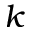Convert formula to latex. <formula><loc_0><loc_0><loc_500><loc_500>k</formula> 